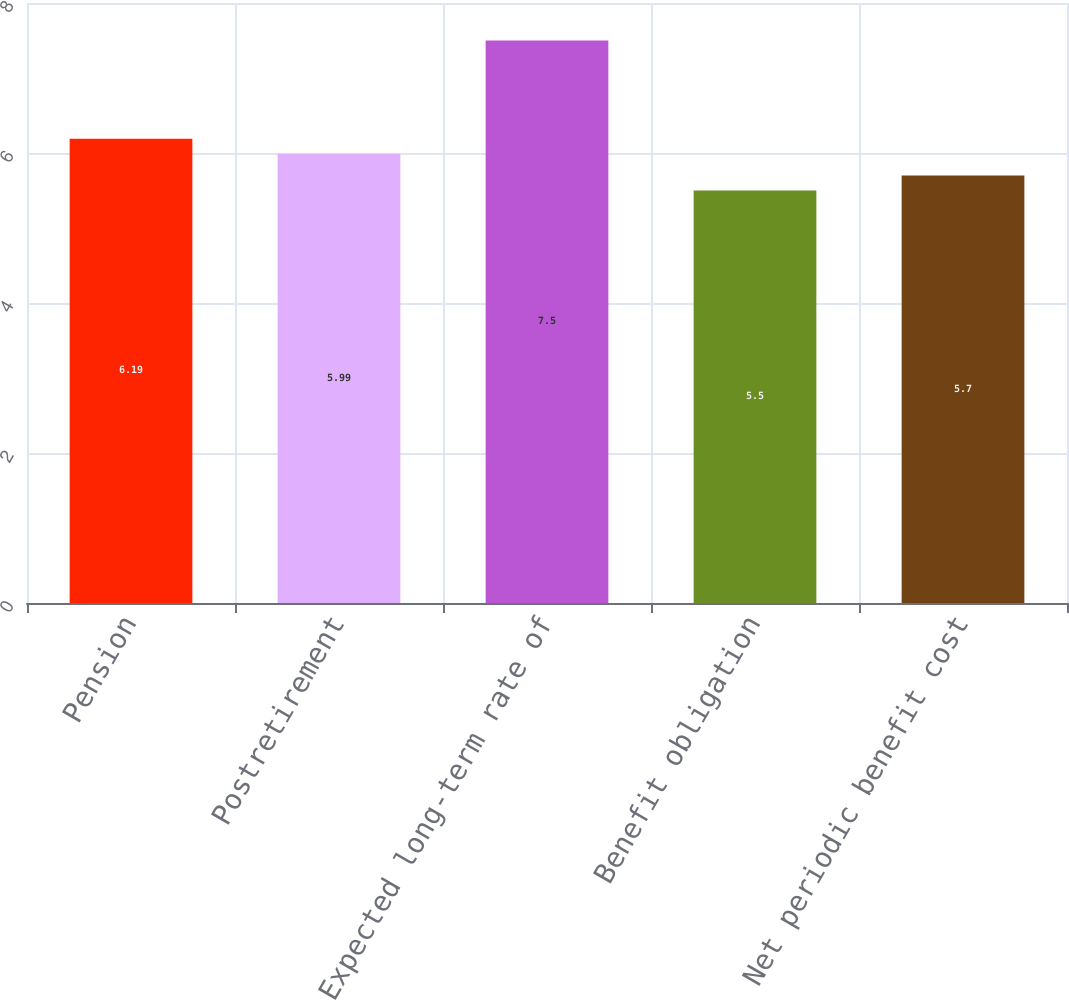<chart> <loc_0><loc_0><loc_500><loc_500><bar_chart><fcel>Pension<fcel>Postretirement<fcel>Expected long-term rate of<fcel>Benefit obligation<fcel>Net periodic benefit cost<nl><fcel>6.19<fcel>5.99<fcel>7.5<fcel>5.5<fcel>5.7<nl></chart> 